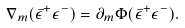<formula> <loc_0><loc_0><loc_500><loc_500>\nabla _ { m } ( \bar { \epsilon } ^ { + } \epsilon ^ { - } ) = \partial _ { m } \Phi ( \bar { \epsilon } ^ { + } \epsilon ^ { - } ) .</formula> 